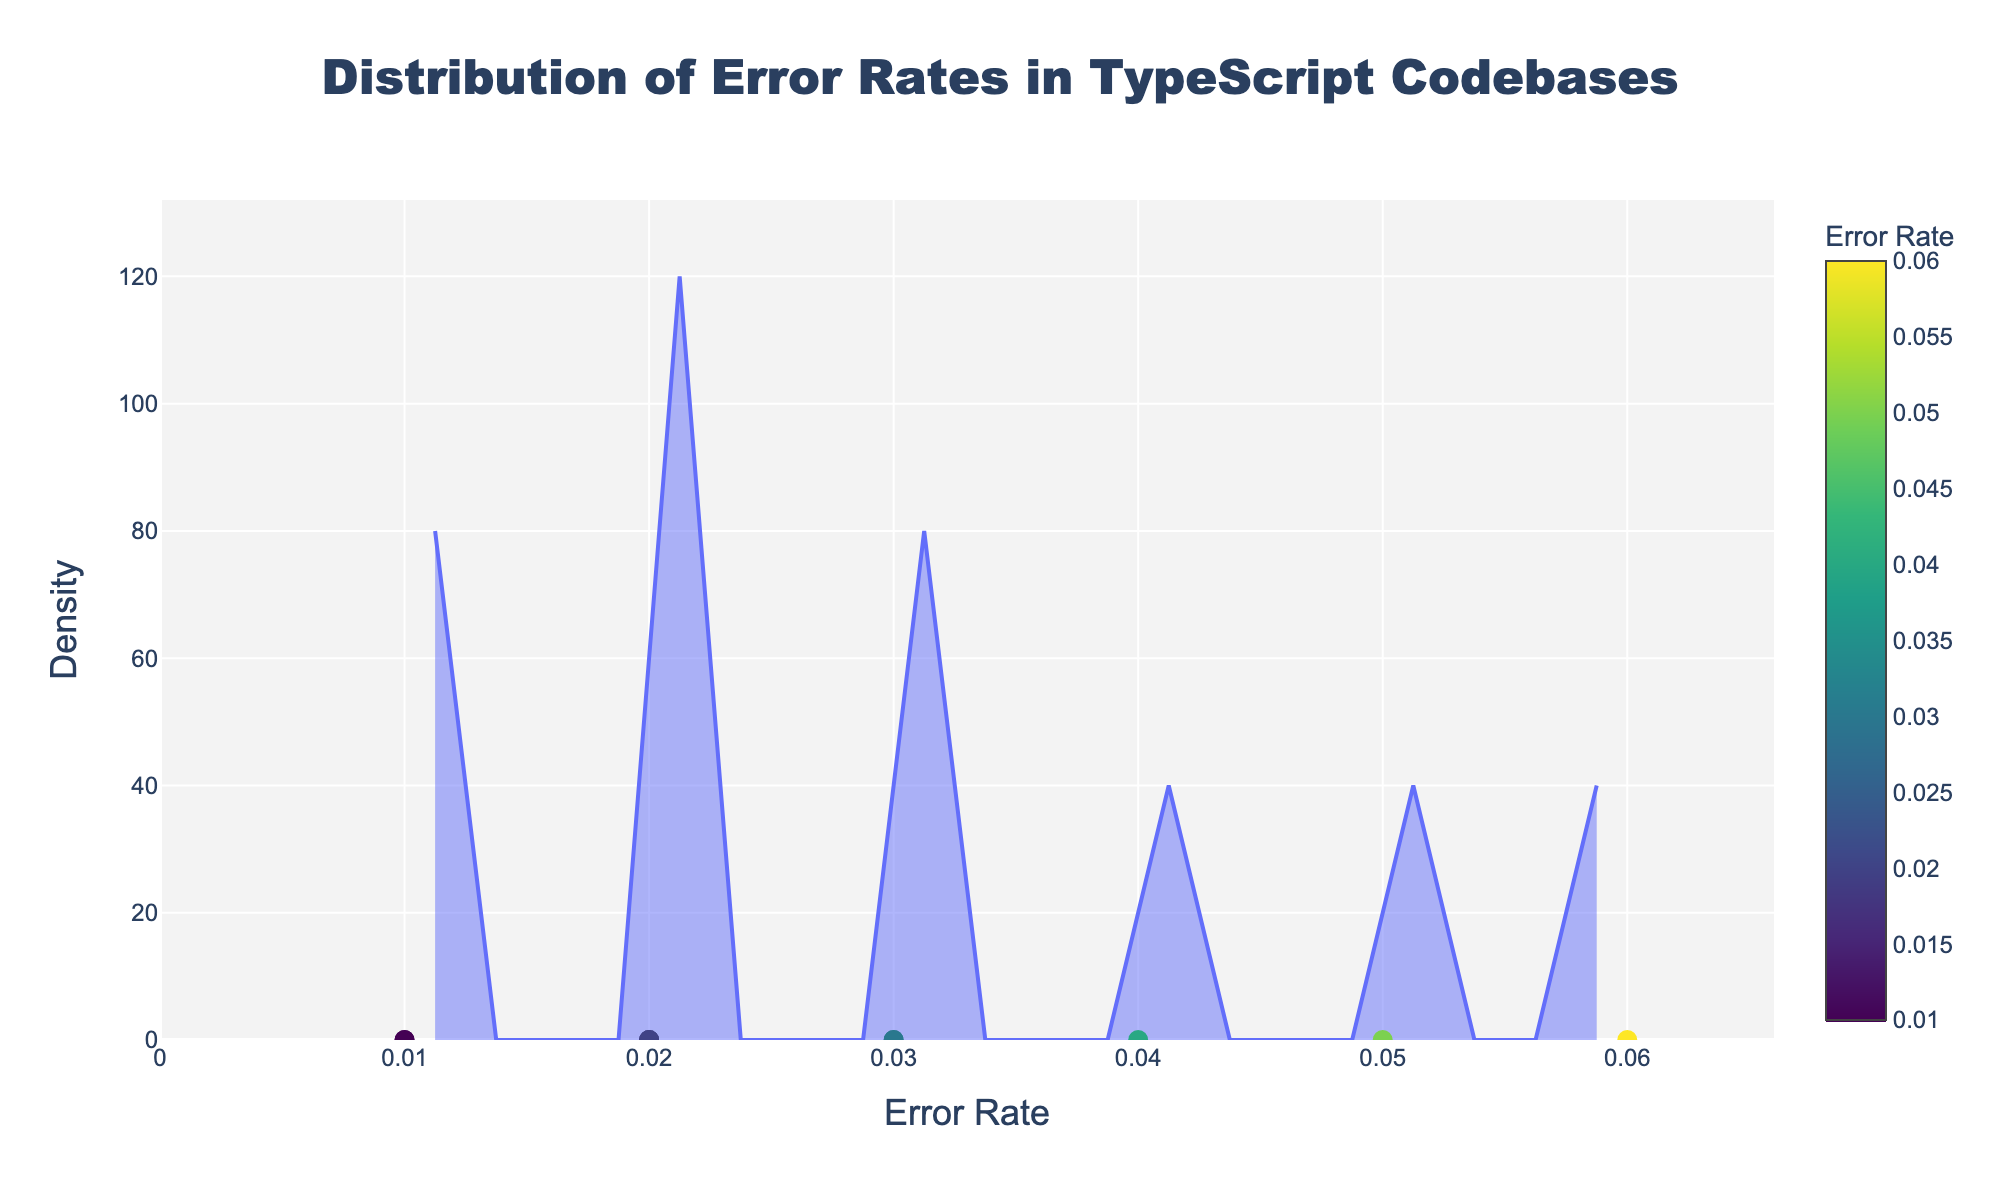What error rate corresponds to the highest density? The figure's highest point on the density curve represents the most frequent error rate.
Answer: 0.03 Which error type has the smallest error rate? The smallest error rate is shown as the leftmost data point on the x-axis, and its corresponding error type is revealed by the hover information.
Answer: EnumMemberListedTwice Are there more error types with an error rate of 0.02 or 0.01? Count the number of data points aligned with these specific error rates along the x-axis. There are two points at 0.02 and two points at 0.01. Both are equal in count.
Answer: Equal Which error type has a higher error rate: NoImplicitAny or StrictNullChecks? Compare the x-axis positions of these two error types' points. NoImplicitAny has a higher error rate than StrictNullChecks.
Answer: NoImplicitAny What is the average error rate of the top three highest density peaks? Identify the top three highest points on the density curve, note their corresponding error rates, and find the average. The error rates are approximately 0.03, 0.05, and 0.06. Average them (0.03 + 0.05 + 0.06) / 3 = 0.0467.
Answer: 0.0467 What’s the total number of error types shown in the figure? Count all the individual data points represented by markers along the x-axis.
Answer: 10 Which error type is closest to the average error rate? Calculate the average of all the error rates: (0.03 + 0.05 + 0.04 + 0.06 + 0.02 + 0.01 + 0.03 + 0.02 + 0.01 + 0.02) / 10 = 0.029, then find the error type whose error rate is closest to this value. The closest is 0.03.
Answer: MissingReturnType and AvoidImplicitAnyIndexErrors 